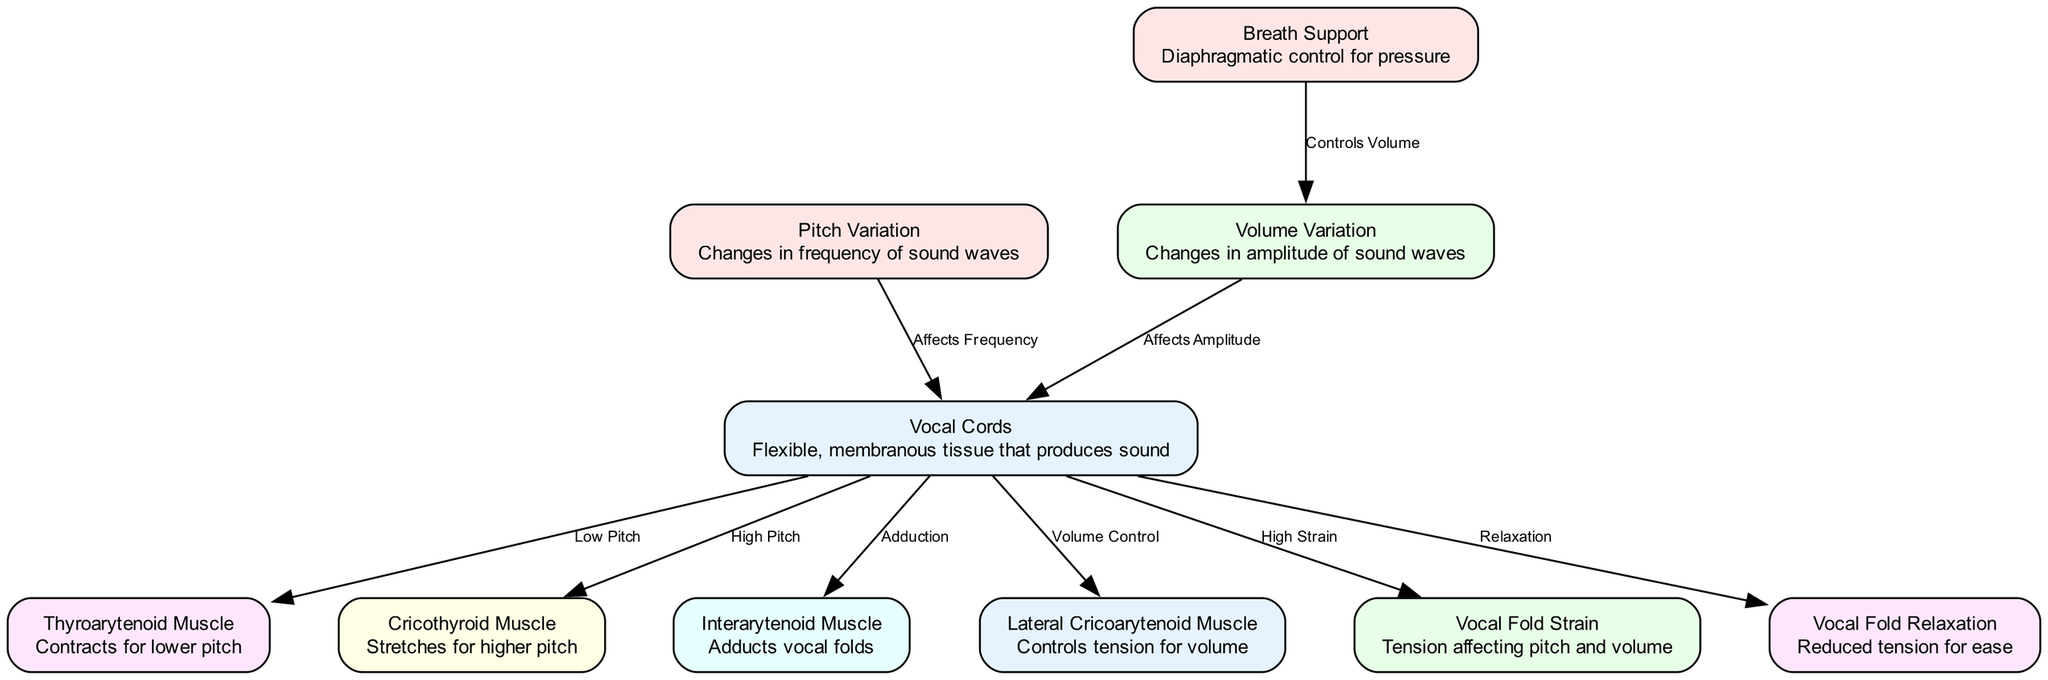What are the two main types of muscle engaged in pitch variation? The diagram shows two key muscles involved with pitch: the Thyroarytenoid Muscle for lower pitch and the Cricothyroid Muscle for higher pitch.
Answer: Thyroarytenoid and Cricothyroid How many nodes are there in this diagram? By counting, the total number of nodes (entities) represented in the diagram is 10.
Answer: 10 What role does the Interarytenoid Muscle play in the vocal cords? The diagram indicates that the Interarytenoid Muscle is responsible for the adduction of the vocal folds, which is essential for sound production.
Answer: Adducts vocal folds Which component controls the breath support in relation to volume variation? The diagram explicitly connects Breath Support to Volume Variation, indicating that breath support helps control volume during singing.
Answer: Breath Support What happens to the vocal folds when high strain occurs? The diagram shows a direct link between vocal cords and vocal fold strain, indicating that high strain affects the tension in the vocal folds, which could lead to potential damage or difficulty in singing.
Answer: High strain affects tension How does breath support affect volume variation? The diagram illustrates that breath support controls volume variation, suggesting that proper breathing techniques are crucial for dynamic volume changes in singing.
Answer: Controls volume What muscle is responsible for controlling tension for volume? The Lateral Cricoarytenoid Muscle is identified in the diagram as the one responsible for controlling tension related to volume.
Answer: Lateral Cricoarytenoid Muscle What is the relationship between vocal fold relaxation and tension? The diagram indicates that vocal fold relaxation occurs when there is reduced tension, highlighting the need for relaxation to ease vocal production.
Answer: Reduced tension for ease 